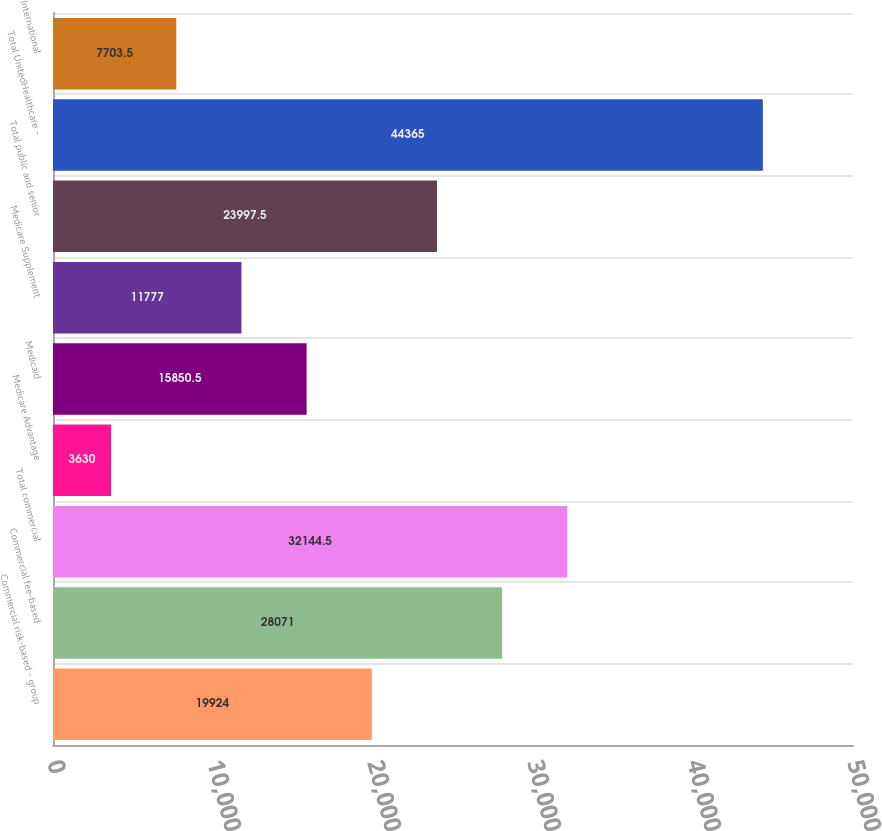Convert chart to OTSL. <chart><loc_0><loc_0><loc_500><loc_500><bar_chart><fcel>Commercial risk-based - group<fcel>Commercial fee-based<fcel>Total commercial<fcel>Medicare Advantage<fcel>Medicaid<fcel>Medicare Supplement<fcel>Total public and senior<fcel>Total UnitedHealthcare -<fcel>International<nl><fcel>19924<fcel>28071<fcel>32144.5<fcel>3630<fcel>15850.5<fcel>11777<fcel>23997.5<fcel>44365<fcel>7703.5<nl></chart> 